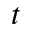Convert formula to latex. <formula><loc_0><loc_0><loc_500><loc_500>t</formula> 